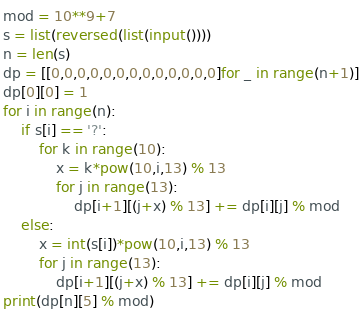<code> <loc_0><loc_0><loc_500><loc_500><_Python_>mod = 10**9+7
s = list(reversed(list(input())))
n = len(s)
dp = [[0,0,0,0,0,0,0,0,0,0,0,0,0]for _ in range(n+1)]
dp[0][0] = 1
for i in range(n):
    if s[i] == '?':
        for k in range(10):
            x = k*pow(10,i,13) % 13
            for j in range(13):
                dp[i+1][(j+x) % 13] += dp[i][j] % mod
    else:
        x = int(s[i])*pow(10,i,13) % 13
        for j in range(13):
            dp[i+1][(j+x) % 13] += dp[i][j] % mod
print(dp[n][5] % mod)

</code> 